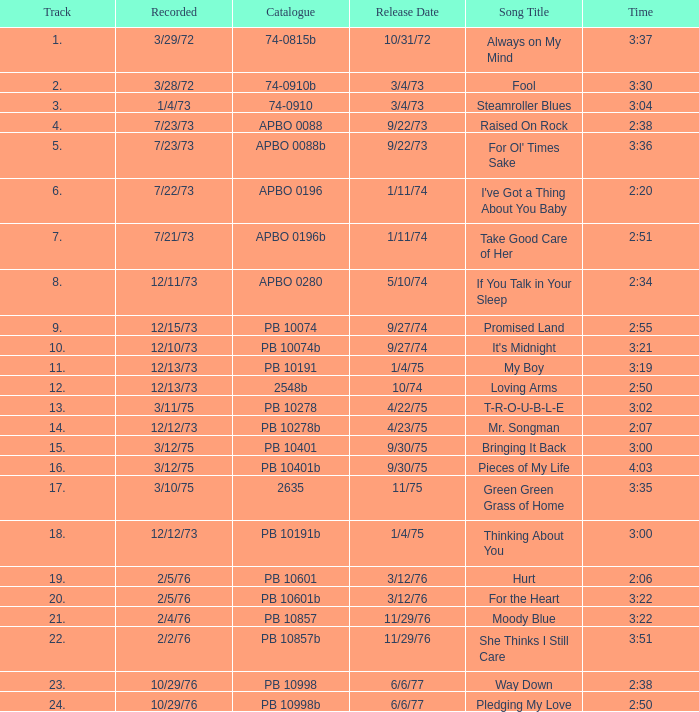How many tracks are there in the raised on rock album? 4.0. 